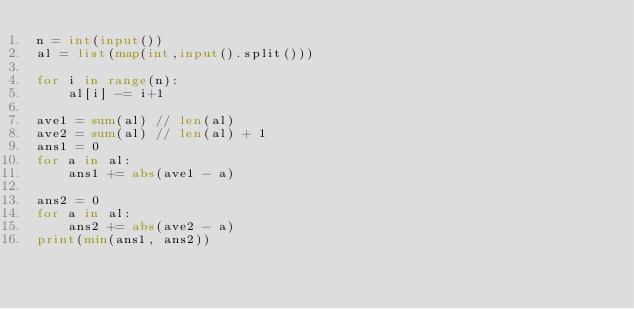<code> <loc_0><loc_0><loc_500><loc_500><_Python_>n = int(input())
al = list(map(int,input().split()))

for i in range(n):
    al[i] -= i+1

ave1 = sum(al) // len(al)
ave2 = sum(al) // len(al) + 1
ans1 = 0
for a in al:
    ans1 += abs(ave1 - a)

ans2 = 0
for a in al:
    ans2 += abs(ave2 - a)
print(min(ans1, ans2))</code> 